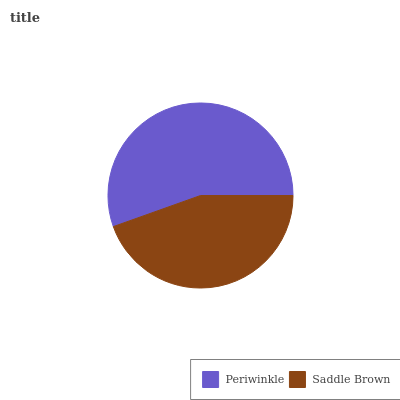Is Saddle Brown the minimum?
Answer yes or no. Yes. Is Periwinkle the maximum?
Answer yes or no. Yes. Is Saddle Brown the maximum?
Answer yes or no. No. Is Periwinkle greater than Saddle Brown?
Answer yes or no. Yes. Is Saddle Brown less than Periwinkle?
Answer yes or no. Yes. Is Saddle Brown greater than Periwinkle?
Answer yes or no. No. Is Periwinkle less than Saddle Brown?
Answer yes or no. No. Is Periwinkle the high median?
Answer yes or no. Yes. Is Saddle Brown the low median?
Answer yes or no. Yes. Is Saddle Brown the high median?
Answer yes or no. No. Is Periwinkle the low median?
Answer yes or no. No. 